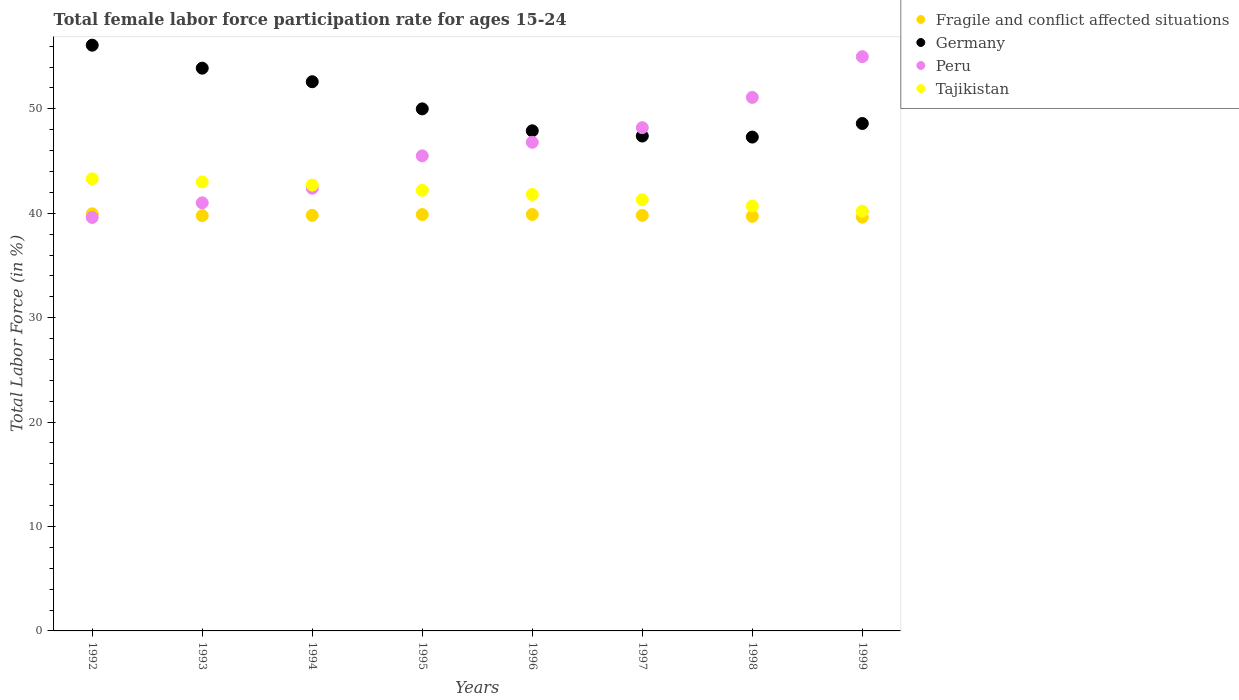Is the number of dotlines equal to the number of legend labels?
Provide a short and direct response. Yes. Across all years, what is the maximum female labor force participation rate in Tajikistan?
Keep it short and to the point. 43.3. Across all years, what is the minimum female labor force participation rate in Peru?
Ensure brevity in your answer.  39.6. What is the total female labor force participation rate in Peru in the graph?
Provide a short and direct response. 369.6. What is the difference between the female labor force participation rate in Germany in 1998 and that in 1999?
Offer a very short reply. -1.3. What is the difference between the female labor force participation rate in Fragile and conflict affected situations in 1998 and the female labor force participation rate in Germany in 1996?
Make the answer very short. -8.19. What is the average female labor force participation rate in Fragile and conflict affected situations per year?
Your response must be concise. 39.8. In the year 1993, what is the difference between the female labor force participation rate in Tajikistan and female labor force participation rate in Fragile and conflict affected situations?
Offer a terse response. 3.23. What is the ratio of the female labor force participation rate in Fragile and conflict affected situations in 1992 to that in 1998?
Your response must be concise. 1.01. Is the difference between the female labor force participation rate in Tajikistan in 1994 and 1999 greater than the difference between the female labor force participation rate in Fragile and conflict affected situations in 1994 and 1999?
Your response must be concise. Yes. What is the difference between the highest and the second highest female labor force participation rate in Tajikistan?
Offer a very short reply. 0.3. What is the difference between the highest and the lowest female labor force participation rate in Tajikistan?
Your answer should be compact. 3.1. In how many years, is the female labor force participation rate in Fragile and conflict affected situations greater than the average female labor force participation rate in Fragile and conflict affected situations taken over all years?
Provide a short and direct response. 4. Is the sum of the female labor force participation rate in Peru in 1997 and 1999 greater than the maximum female labor force participation rate in Tajikistan across all years?
Your answer should be very brief. Yes. Is it the case that in every year, the sum of the female labor force participation rate in Peru and female labor force participation rate in Germany  is greater than the female labor force participation rate in Tajikistan?
Your answer should be very brief. Yes. Is the female labor force participation rate in Fragile and conflict affected situations strictly less than the female labor force participation rate in Germany over the years?
Your response must be concise. Yes. How many years are there in the graph?
Provide a short and direct response. 8. Where does the legend appear in the graph?
Offer a very short reply. Top right. How many legend labels are there?
Your answer should be compact. 4. How are the legend labels stacked?
Make the answer very short. Vertical. What is the title of the graph?
Offer a very short reply. Total female labor force participation rate for ages 15-24. What is the Total Labor Force (in %) of Fragile and conflict affected situations in 1992?
Offer a very short reply. 39.95. What is the Total Labor Force (in %) of Germany in 1992?
Provide a succinct answer. 56.1. What is the Total Labor Force (in %) of Peru in 1992?
Give a very brief answer. 39.6. What is the Total Labor Force (in %) in Tajikistan in 1992?
Provide a short and direct response. 43.3. What is the Total Labor Force (in %) of Fragile and conflict affected situations in 1993?
Offer a very short reply. 39.77. What is the Total Labor Force (in %) in Germany in 1993?
Your answer should be very brief. 53.9. What is the Total Labor Force (in %) of Fragile and conflict affected situations in 1994?
Your answer should be very brief. 39.8. What is the Total Labor Force (in %) of Germany in 1994?
Offer a very short reply. 52.6. What is the Total Labor Force (in %) of Peru in 1994?
Keep it short and to the point. 42.4. What is the Total Labor Force (in %) of Tajikistan in 1994?
Offer a terse response. 42.7. What is the Total Labor Force (in %) of Fragile and conflict affected situations in 1995?
Give a very brief answer. 39.88. What is the Total Labor Force (in %) of Peru in 1995?
Make the answer very short. 45.5. What is the Total Labor Force (in %) in Tajikistan in 1995?
Give a very brief answer. 42.2. What is the Total Labor Force (in %) in Fragile and conflict affected situations in 1996?
Your answer should be very brief. 39.89. What is the Total Labor Force (in %) of Germany in 1996?
Ensure brevity in your answer.  47.9. What is the Total Labor Force (in %) in Peru in 1996?
Your response must be concise. 46.8. What is the Total Labor Force (in %) of Tajikistan in 1996?
Offer a very short reply. 41.8. What is the Total Labor Force (in %) of Fragile and conflict affected situations in 1997?
Give a very brief answer. 39.8. What is the Total Labor Force (in %) in Germany in 1997?
Offer a very short reply. 47.4. What is the Total Labor Force (in %) in Peru in 1997?
Provide a succinct answer. 48.2. What is the Total Labor Force (in %) of Tajikistan in 1997?
Offer a very short reply. 41.3. What is the Total Labor Force (in %) of Fragile and conflict affected situations in 1998?
Offer a very short reply. 39.71. What is the Total Labor Force (in %) in Germany in 1998?
Make the answer very short. 47.3. What is the Total Labor Force (in %) of Peru in 1998?
Keep it short and to the point. 51.1. What is the Total Labor Force (in %) in Tajikistan in 1998?
Offer a very short reply. 40.7. What is the Total Labor Force (in %) of Fragile and conflict affected situations in 1999?
Ensure brevity in your answer.  39.63. What is the Total Labor Force (in %) of Germany in 1999?
Make the answer very short. 48.6. What is the Total Labor Force (in %) of Tajikistan in 1999?
Your response must be concise. 40.2. Across all years, what is the maximum Total Labor Force (in %) of Fragile and conflict affected situations?
Your answer should be very brief. 39.95. Across all years, what is the maximum Total Labor Force (in %) of Germany?
Your answer should be very brief. 56.1. Across all years, what is the maximum Total Labor Force (in %) in Peru?
Your answer should be compact. 55. Across all years, what is the maximum Total Labor Force (in %) of Tajikistan?
Your answer should be very brief. 43.3. Across all years, what is the minimum Total Labor Force (in %) of Fragile and conflict affected situations?
Provide a short and direct response. 39.63. Across all years, what is the minimum Total Labor Force (in %) of Germany?
Offer a very short reply. 47.3. Across all years, what is the minimum Total Labor Force (in %) in Peru?
Offer a terse response. 39.6. Across all years, what is the minimum Total Labor Force (in %) of Tajikistan?
Make the answer very short. 40.2. What is the total Total Labor Force (in %) of Fragile and conflict affected situations in the graph?
Make the answer very short. 318.42. What is the total Total Labor Force (in %) in Germany in the graph?
Give a very brief answer. 403.8. What is the total Total Labor Force (in %) of Peru in the graph?
Make the answer very short. 369.6. What is the total Total Labor Force (in %) of Tajikistan in the graph?
Provide a succinct answer. 335.2. What is the difference between the Total Labor Force (in %) of Fragile and conflict affected situations in 1992 and that in 1993?
Give a very brief answer. 0.18. What is the difference between the Total Labor Force (in %) in Germany in 1992 and that in 1993?
Make the answer very short. 2.2. What is the difference between the Total Labor Force (in %) of Fragile and conflict affected situations in 1992 and that in 1994?
Give a very brief answer. 0.15. What is the difference between the Total Labor Force (in %) in Tajikistan in 1992 and that in 1994?
Make the answer very short. 0.6. What is the difference between the Total Labor Force (in %) of Fragile and conflict affected situations in 1992 and that in 1995?
Offer a very short reply. 0.07. What is the difference between the Total Labor Force (in %) in Fragile and conflict affected situations in 1992 and that in 1996?
Offer a very short reply. 0.06. What is the difference between the Total Labor Force (in %) of Peru in 1992 and that in 1996?
Provide a short and direct response. -7.2. What is the difference between the Total Labor Force (in %) in Fragile and conflict affected situations in 1992 and that in 1997?
Offer a very short reply. 0.15. What is the difference between the Total Labor Force (in %) in Germany in 1992 and that in 1997?
Your response must be concise. 8.7. What is the difference between the Total Labor Force (in %) of Peru in 1992 and that in 1997?
Offer a very short reply. -8.6. What is the difference between the Total Labor Force (in %) in Tajikistan in 1992 and that in 1997?
Provide a succinct answer. 2. What is the difference between the Total Labor Force (in %) in Fragile and conflict affected situations in 1992 and that in 1998?
Make the answer very short. 0.24. What is the difference between the Total Labor Force (in %) in Germany in 1992 and that in 1998?
Ensure brevity in your answer.  8.8. What is the difference between the Total Labor Force (in %) of Tajikistan in 1992 and that in 1998?
Provide a succinct answer. 2.6. What is the difference between the Total Labor Force (in %) of Fragile and conflict affected situations in 1992 and that in 1999?
Provide a short and direct response. 0.32. What is the difference between the Total Labor Force (in %) of Peru in 1992 and that in 1999?
Keep it short and to the point. -15.4. What is the difference between the Total Labor Force (in %) of Fragile and conflict affected situations in 1993 and that in 1994?
Keep it short and to the point. -0.03. What is the difference between the Total Labor Force (in %) in Tajikistan in 1993 and that in 1994?
Make the answer very short. 0.3. What is the difference between the Total Labor Force (in %) in Fragile and conflict affected situations in 1993 and that in 1995?
Give a very brief answer. -0.1. What is the difference between the Total Labor Force (in %) in Peru in 1993 and that in 1995?
Make the answer very short. -4.5. What is the difference between the Total Labor Force (in %) of Fragile and conflict affected situations in 1993 and that in 1996?
Ensure brevity in your answer.  -0.11. What is the difference between the Total Labor Force (in %) of Fragile and conflict affected situations in 1993 and that in 1997?
Give a very brief answer. -0.03. What is the difference between the Total Labor Force (in %) in Peru in 1993 and that in 1997?
Your response must be concise. -7.2. What is the difference between the Total Labor Force (in %) in Tajikistan in 1993 and that in 1997?
Provide a succinct answer. 1.7. What is the difference between the Total Labor Force (in %) in Fragile and conflict affected situations in 1993 and that in 1998?
Offer a terse response. 0.06. What is the difference between the Total Labor Force (in %) in Peru in 1993 and that in 1998?
Provide a short and direct response. -10.1. What is the difference between the Total Labor Force (in %) of Fragile and conflict affected situations in 1993 and that in 1999?
Provide a succinct answer. 0.15. What is the difference between the Total Labor Force (in %) in Germany in 1993 and that in 1999?
Your response must be concise. 5.3. What is the difference between the Total Labor Force (in %) of Tajikistan in 1993 and that in 1999?
Ensure brevity in your answer.  2.8. What is the difference between the Total Labor Force (in %) of Fragile and conflict affected situations in 1994 and that in 1995?
Offer a very short reply. -0.07. What is the difference between the Total Labor Force (in %) in Germany in 1994 and that in 1995?
Your response must be concise. 2.6. What is the difference between the Total Labor Force (in %) of Fragile and conflict affected situations in 1994 and that in 1996?
Your answer should be compact. -0.08. What is the difference between the Total Labor Force (in %) in Germany in 1994 and that in 1996?
Your response must be concise. 4.7. What is the difference between the Total Labor Force (in %) of Fragile and conflict affected situations in 1994 and that in 1997?
Offer a very short reply. 0. What is the difference between the Total Labor Force (in %) of Germany in 1994 and that in 1997?
Provide a succinct answer. 5.2. What is the difference between the Total Labor Force (in %) of Peru in 1994 and that in 1997?
Your answer should be compact. -5.8. What is the difference between the Total Labor Force (in %) in Tajikistan in 1994 and that in 1997?
Ensure brevity in your answer.  1.4. What is the difference between the Total Labor Force (in %) in Fragile and conflict affected situations in 1994 and that in 1998?
Provide a succinct answer. 0.09. What is the difference between the Total Labor Force (in %) of Peru in 1994 and that in 1998?
Offer a terse response. -8.7. What is the difference between the Total Labor Force (in %) in Tajikistan in 1994 and that in 1998?
Keep it short and to the point. 2. What is the difference between the Total Labor Force (in %) in Fragile and conflict affected situations in 1994 and that in 1999?
Your answer should be very brief. 0.18. What is the difference between the Total Labor Force (in %) of Germany in 1994 and that in 1999?
Provide a short and direct response. 4. What is the difference between the Total Labor Force (in %) of Tajikistan in 1994 and that in 1999?
Offer a terse response. 2.5. What is the difference between the Total Labor Force (in %) of Fragile and conflict affected situations in 1995 and that in 1996?
Your response must be concise. -0.01. What is the difference between the Total Labor Force (in %) of Germany in 1995 and that in 1996?
Give a very brief answer. 2.1. What is the difference between the Total Labor Force (in %) of Peru in 1995 and that in 1996?
Ensure brevity in your answer.  -1.3. What is the difference between the Total Labor Force (in %) in Tajikistan in 1995 and that in 1996?
Offer a very short reply. 0.4. What is the difference between the Total Labor Force (in %) in Fragile and conflict affected situations in 1995 and that in 1997?
Give a very brief answer. 0.08. What is the difference between the Total Labor Force (in %) in Peru in 1995 and that in 1997?
Provide a short and direct response. -2.7. What is the difference between the Total Labor Force (in %) of Tajikistan in 1995 and that in 1997?
Provide a succinct answer. 0.9. What is the difference between the Total Labor Force (in %) in Fragile and conflict affected situations in 1995 and that in 1998?
Ensure brevity in your answer.  0.17. What is the difference between the Total Labor Force (in %) in Peru in 1995 and that in 1998?
Give a very brief answer. -5.6. What is the difference between the Total Labor Force (in %) of Fragile and conflict affected situations in 1995 and that in 1999?
Ensure brevity in your answer.  0.25. What is the difference between the Total Labor Force (in %) of Germany in 1995 and that in 1999?
Give a very brief answer. 1.4. What is the difference between the Total Labor Force (in %) of Peru in 1995 and that in 1999?
Your response must be concise. -9.5. What is the difference between the Total Labor Force (in %) of Tajikistan in 1995 and that in 1999?
Offer a terse response. 2. What is the difference between the Total Labor Force (in %) of Fragile and conflict affected situations in 1996 and that in 1997?
Ensure brevity in your answer.  0.09. What is the difference between the Total Labor Force (in %) in Germany in 1996 and that in 1997?
Your response must be concise. 0.5. What is the difference between the Total Labor Force (in %) of Peru in 1996 and that in 1997?
Offer a very short reply. -1.4. What is the difference between the Total Labor Force (in %) in Tajikistan in 1996 and that in 1997?
Offer a terse response. 0.5. What is the difference between the Total Labor Force (in %) in Fragile and conflict affected situations in 1996 and that in 1998?
Provide a short and direct response. 0.18. What is the difference between the Total Labor Force (in %) of Germany in 1996 and that in 1998?
Provide a short and direct response. 0.6. What is the difference between the Total Labor Force (in %) in Peru in 1996 and that in 1998?
Keep it short and to the point. -4.3. What is the difference between the Total Labor Force (in %) of Tajikistan in 1996 and that in 1998?
Provide a succinct answer. 1.1. What is the difference between the Total Labor Force (in %) of Fragile and conflict affected situations in 1996 and that in 1999?
Your response must be concise. 0.26. What is the difference between the Total Labor Force (in %) of Germany in 1996 and that in 1999?
Ensure brevity in your answer.  -0.7. What is the difference between the Total Labor Force (in %) of Fragile and conflict affected situations in 1997 and that in 1998?
Offer a very short reply. 0.09. What is the difference between the Total Labor Force (in %) of Peru in 1997 and that in 1998?
Provide a succinct answer. -2.9. What is the difference between the Total Labor Force (in %) of Tajikistan in 1997 and that in 1998?
Your answer should be compact. 0.6. What is the difference between the Total Labor Force (in %) of Fragile and conflict affected situations in 1997 and that in 1999?
Make the answer very short. 0.17. What is the difference between the Total Labor Force (in %) of Germany in 1997 and that in 1999?
Offer a very short reply. -1.2. What is the difference between the Total Labor Force (in %) of Tajikistan in 1997 and that in 1999?
Give a very brief answer. 1.1. What is the difference between the Total Labor Force (in %) of Fragile and conflict affected situations in 1998 and that in 1999?
Give a very brief answer. 0.08. What is the difference between the Total Labor Force (in %) of Tajikistan in 1998 and that in 1999?
Ensure brevity in your answer.  0.5. What is the difference between the Total Labor Force (in %) in Fragile and conflict affected situations in 1992 and the Total Labor Force (in %) in Germany in 1993?
Your answer should be very brief. -13.95. What is the difference between the Total Labor Force (in %) in Fragile and conflict affected situations in 1992 and the Total Labor Force (in %) in Peru in 1993?
Give a very brief answer. -1.05. What is the difference between the Total Labor Force (in %) in Fragile and conflict affected situations in 1992 and the Total Labor Force (in %) in Tajikistan in 1993?
Keep it short and to the point. -3.05. What is the difference between the Total Labor Force (in %) in Germany in 1992 and the Total Labor Force (in %) in Peru in 1993?
Your response must be concise. 15.1. What is the difference between the Total Labor Force (in %) in Peru in 1992 and the Total Labor Force (in %) in Tajikistan in 1993?
Make the answer very short. -3.4. What is the difference between the Total Labor Force (in %) of Fragile and conflict affected situations in 1992 and the Total Labor Force (in %) of Germany in 1994?
Offer a very short reply. -12.65. What is the difference between the Total Labor Force (in %) in Fragile and conflict affected situations in 1992 and the Total Labor Force (in %) in Peru in 1994?
Make the answer very short. -2.45. What is the difference between the Total Labor Force (in %) of Fragile and conflict affected situations in 1992 and the Total Labor Force (in %) of Tajikistan in 1994?
Offer a terse response. -2.75. What is the difference between the Total Labor Force (in %) in Germany in 1992 and the Total Labor Force (in %) in Tajikistan in 1994?
Make the answer very short. 13.4. What is the difference between the Total Labor Force (in %) of Fragile and conflict affected situations in 1992 and the Total Labor Force (in %) of Germany in 1995?
Your answer should be compact. -10.05. What is the difference between the Total Labor Force (in %) in Fragile and conflict affected situations in 1992 and the Total Labor Force (in %) in Peru in 1995?
Make the answer very short. -5.55. What is the difference between the Total Labor Force (in %) in Fragile and conflict affected situations in 1992 and the Total Labor Force (in %) in Tajikistan in 1995?
Your answer should be compact. -2.25. What is the difference between the Total Labor Force (in %) in Germany in 1992 and the Total Labor Force (in %) in Tajikistan in 1995?
Your answer should be compact. 13.9. What is the difference between the Total Labor Force (in %) in Fragile and conflict affected situations in 1992 and the Total Labor Force (in %) in Germany in 1996?
Offer a very short reply. -7.95. What is the difference between the Total Labor Force (in %) of Fragile and conflict affected situations in 1992 and the Total Labor Force (in %) of Peru in 1996?
Provide a succinct answer. -6.85. What is the difference between the Total Labor Force (in %) in Fragile and conflict affected situations in 1992 and the Total Labor Force (in %) in Tajikistan in 1996?
Offer a terse response. -1.85. What is the difference between the Total Labor Force (in %) in Germany in 1992 and the Total Labor Force (in %) in Tajikistan in 1996?
Your answer should be very brief. 14.3. What is the difference between the Total Labor Force (in %) in Peru in 1992 and the Total Labor Force (in %) in Tajikistan in 1996?
Your answer should be very brief. -2.2. What is the difference between the Total Labor Force (in %) in Fragile and conflict affected situations in 1992 and the Total Labor Force (in %) in Germany in 1997?
Your answer should be very brief. -7.45. What is the difference between the Total Labor Force (in %) in Fragile and conflict affected situations in 1992 and the Total Labor Force (in %) in Peru in 1997?
Provide a succinct answer. -8.25. What is the difference between the Total Labor Force (in %) of Fragile and conflict affected situations in 1992 and the Total Labor Force (in %) of Tajikistan in 1997?
Your response must be concise. -1.35. What is the difference between the Total Labor Force (in %) in Peru in 1992 and the Total Labor Force (in %) in Tajikistan in 1997?
Your answer should be very brief. -1.7. What is the difference between the Total Labor Force (in %) of Fragile and conflict affected situations in 1992 and the Total Labor Force (in %) of Germany in 1998?
Provide a succinct answer. -7.35. What is the difference between the Total Labor Force (in %) of Fragile and conflict affected situations in 1992 and the Total Labor Force (in %) of Peru in 1998?
Offer a very short reply. -11.15. What is the difference between the Total Labor Force (in %) of Fragile and conflict affected situations in 1992 and the Total Labor Force (in %) of Tajikistan in 1998?
Provide a succinct answer. -0.75. What is the difference between the Total Labor Force (in %) in Germany in 1992 and the Total Labor Force (in %) in Peru in 1998?
Offer a very short reply. 5. What is the difference between the Total Labor Force (in %) in Fragile and conflict affected situations in 1992 and the Total Labor Force (in %) in Germany in 1999?
Provide a short and direct response. -8.65. What is the difference between the Total Labor Force (in %) of Fragile and conflict affected situations in 1992 and the Total Labor Force (in %) of Peru in 1999?
Ensure brevity in your answer.  -15.05. What is the difference between the Total Labor Force (in %) in Fragile and conflict affected situations in 1992 and the Total Labor Force (in %) in Tajikistan in 1999?
Give a very brief answer. -0.25. What is the difference between the Total Labor Force (in %) of Germany in 1992 and the Total Labor Force (in %) of Peru in 1999?
Provide a short and direct response. 1.1. What is the difference between the Total Labor Force (in %) in Germany in 1992 and the Total Labor Force (in %) in Tajikistan in 1999?
Ensure brevity in your answer.  15.9. What is the difference between the Total Labor Force (in %) of Fragile and conflict affected situations in 1993 and the Total Labor Force (in %) of Germany in 1994?
Your answer should be compact. -12.83. What is the difference between the Total Labor Force (in %) in Fragile and conflict affected situations in 1993 and the Total Labor Force (in %) in Peru in 1994?
Offer a terse response. -2.63. What is the difference between the Total Labor Force (in %) in Fragile and conflict affected situations in 1993 and the Total Labor Force (in %) in Tajikistan in 1994?
Provide a short and direct response. -2.93. What is the difference between the Total Labor Force (in %) in Peru in 1993 and the Total Labor Force (in %) in Tajikistan in 1994?
Your answer should be compact. -1.7. What is the difference between the Total Labor Force (in %) in Fragile and conflict affected situations in 1993 and the Total Labor Force (in %) in Germany in 1995?
Give a very brief answer. -10.23. What is the difference between the Total Labor Force (in %) of Fragile and conflict affected situations in 1993 and the Total Labor Force (in %) of Peru in 1995?
Offer a terse response. -5.73. What is the difference between the Total Labor Force (in %) of Fragile and conflict affected situations in 1993 and the Total Labor Force (in %) of Tajikistan in 1995?
Offer a terse response. -2.43. What is the difference between the Total Labor Force (in %) in Fragile and conflict affected situations in 1993 and the Total Labor Force (in %) in Germany in 1996?
Make the answer very short. -8.13. What is the difference between the Total Labor Force (in %) in Fragile and conflict affected situations in 1993 and the Total Labor Force (in %) in Peru in 1996?
Your answer should be compact. -7.03. What is the difference between the Total Labor Force (in %) in Fragile and conflict affected situations in 1993 and the Total Labor Force (in %) in Tajikistan in 1996?
Your answer should be very brief. -2.03. What is the difference between the Total Labor Force (in %) in Germany in 1993 and the Total Labor Force (in %) in Peru in 1996?
Offer a terse response. 7.1. What is the difference between the Total Labor Force (in %) in Fragile and conflict affected situations in 1993 and the Total Labor Force (in %) in Germany in 1997?
Offer a terse response. -7.63. What is the difference between the Total Labor Force (in %) in Fragile and conflict affected situations in 1993 and the Total Labor Force (in %) in Peru in 1997?
Your answer should be very brief. -8.43. What is the difference between the Total Labor Force (in %) in Fragile and conflict affected situations in 1993 and the Total Labor Force (in %) in Tajikistan in 1997?
Your response must be concise. -1.53. What is the difference between the Total Labor Force (in %) of Germany in 1993 and the Total Labor Force (in %) of Peru in 1997?
Your answer should be compact. 5.7. What is the difference between the Total Labor Force (in %) in Germany in 1993 and the Total Labor Force (in %) in Tajikistan in 1997?
Your answer should be compact. 12.6. What is the difference between the Total Labor Force (in %) of Fragile and conflict affected situations in 1993 and the Total Labor Force (in %) of Germany in 1998?
Make the answer very short. -7.53. What is the difference between the Total Labor Force (in %) in Fragile and conflict affected situations in 1993 and the Total Labor Force (in %) in Peru in 1998?
Offer a terse response. -11.33. What is the difference between the Total Labor Force (in %) of Fragile and conflict affected situations in 1993 and the Total Labor Force (in %) of Tajikistan in 1998?
Keep it short and to the point. -0.93. What is the difference between the Total Labor Force (in %) in Germany in 1993 and the Total Labor Force (in %) in Tajikistan in 1998?
Provide a short and direct response. 13.2. What is the difference between the Total Labor Force (in %) of Peru in 1993 and the Total Labor Force (in %) of Tajikistan in 1998?
Make the answer very short. 0.3. What is the difference between the Total Labor Force (in %) of Fragile and conflict affected situations in 1993 and the Total Labor Force (in %) of Germany in 1999?
Your answer should be compact. -8.83. What is the difference between the Total Labor Force (in %) in Fragile and conflict affected situations in 1993 and the Total Labor Force (in %) in Peru in 1999?
Offer a terse response. -15.23. What is the difference between the Total Labor Force (in %) in Fragile and conflict affected situations in 1993 and the Total Labor Force (in %) in Tajikistan in 1999?
Offer a very short reply. -0.43. What is the difference between the Total Labor Force (in %) of Germany in 1993 and the Total Labor Force (in %) of Peru in 1999?
Keep it short and to the point. -1.1. What is the difference between the Total Labor Force (in %) in Germany in 1993 and the Total Labor Force (in %) in Tajikistan in 1999?
Provide a short and direct response. 13.7. What is the difference between the Total Labor Force (in %) of Peru in 1993 and the Total Labor Force (in %) of Tajikistan in 1999?
Your answer should be very brief. 0.8. What is the difference between the Total Labor Force (in %) in Fragile and conflict affected situations in 1994 and the Total Labor Force (in %) in Germany in 1995?
Make the answer very short. -10.2. What is the difference between the Total Labor Force (in %) of Fragile and conflict affected situations in 1994 and the Total Labor Force (in %) of Peru in 1995?
Give a very brief answer. -5.7. What is the difference between the Total Labor Force (in %) of Fragile and conflict affected situations in 1994 and the Total Labor Force (in %) of Tajikistan in 1995?
Make the answer very short. -2.4. What is the difference between the Total Labor Force (in %) of Germany in 1994 and the Total Labor Force (in %) of Peru in 1995?
Provide a short and direct response. 7.1. What is the difference between the Total Labor Force (in %) in Fragile and conflict affected situations in 1994 and the Total Labor Force (in %) in Germany in 1996?
Give a very brief answer. -8.1. What is the difference between the Total Labor Force (in %) in Fragile and conflict affected situations in 1994 and the Total Labor Force (in %) in Peru in 1996?
Offer a very short reply. -7. What is the difference between the Total Labor Force (in %) of Fragile and conflict affected situations in 1994 and the Total Labor Force (in %) of Tajikistan in 1996?
Give a very brief answer. -2. What is the difference between the Total Labor Force (in %) in Germany in 1994 and the Total Labor Force (in %) in Tajikistan in 1996?
Offer a terse response. 10.8. What is the difference between the Total Labor Force (in %) of Peru in 1994 and the Total Labor Force (in %) of Tajikistan in 1996?
Your answer should be compact. 0.6. What is the difference between the Total Labor Force (in %) of Fragile and conflict affected situations in 1994 and the Total Labor Force (in %) of Germany in 1997?
Provide a succinct answer. -7.6. What is the difference between the Total Labor Force (in %) in Fragile and conflict affected situations in 1994 and the Total Labor Force (in %) in Peru in 1997?
Your answer should be compact. -8.4. What is the difference between the Total Labor Force (in %) of Fragile and conflict affected situations in 1994 and the Total Labor Force (in %) of Tajikistan in 1997?
Offer a very short reply. -1.5. What is the difference between the Total Labor Force (in %) in Germany in 1994 and the Total Labor Force (in %) in Peru in 1997?
Provide a succinct answer. 4.4. What is the difference between the Total Labor Force (in %) of Fragile and conflict affected situations in 1994 and the Total Labor Force (in %) of Germany in 1998?
Ensure brevity in your answer.  -7.5. What is the difference between the Total Labor Force (in %) of Fragile and conflict affected situations in 1994 and the Total Labor Force (in %) of Peru in 1998?
Offer a terse response. -11.3. What is the difference between the Total Labor Force (in %) in Fragile and conflict affected situations in 1994 and the Total Labor Force (in %) in Tajikistan in 1998?
Keep it short and to the point. -0.9. What is the difference between the Total Labor Force (in %) of Germany in 1994 and the Total Labor Force (in %) of Peru in 1998?
Your answer should be very brief. 1.5. What is the difference between the Total Labor Force (in %) of Peru in 1994 and the Total Labor Force (in %) of Tajikistan in 1998?
Offer a terse response. 1.7. What is the difference between the Total Labor Force (in %) in Fragile and conflict affected situations in 1994 and the Total Labor Force (in %) in Germany in 1999?
Your answer should be very brief. -8.8. What is the difference between the Total Labor Force (in %) of Fragile and conflict affected situations in 1994 and the Total Labor Force (in %) of Peru in 1999?
Your answer should be very brief. -15.2. What is the difference between the Total Labor Force (in %) in Fragile and conflict affected situations in 1994 and the Total Labor Force (in %) in Tajikistan in 1999?
Keep it short and to the point. -0.4. What is the difference between the Total Labor Force (in %) of Germany in 1994 and the Total Labor Force (in %) of Tajikistan in 1999?
Provide a short and direct response. 12.4. What is the difference between the Total Labor Force (in %) in Peru in 1994 and the Total Labor Force (in %) in Tajikistan in 1999?
Keep it short and to the point. 2.2. What is the difference between the Total Labor Force (in %) of Fragile and conflict affected situations in 1995 and the Total Labor Force (in %) of Germany in 1996?
Ensure brevity in your answer.  -8.03. What is the difference between the Total Labor Force (in %) in Fragile and conflict affected situations in 1995 and the Total Labor Force (in %) in Peru in 1996?
Your response must be concise. -6.92. What is the difference between the Total Labor Force (in %) in Fragile and conflict affected situations in 1995 and the Total Labor Force (in %) in Tajikistan in 1996?
Provide a short and direct response. -1.93. What is the difference between the Total Labor Force (in %) of Germany in 1995 and the Total Labor Force (in %) of Tajikistan in 1996?
Keep it short and to the point. 8.2. What is the difference between the Total Labor Force (in %) of Peru in 1995 and the Total Labor Force (in %) of Tajikistan in 1996?
Give a very brief answer. 3.7. What is the difference between the Total Labor Force (in %) in Fragile and conflict affected situations in 1995 and the Total Labor Force (in %) in Germany in 1997?
Your answer should be compact. -7.53. What is the difference between the Total Labor Force (in %) of Fragile and conflict affected situations in 1995 and the Total Labor Force (in %) of Peru in 1997?
Keep it short and to the point. -8.32. What is the difference between the Total Labor Force (in %) in Fragile and conflict affected situations in 1995 and the Total Labor Force (in %) in Tajikistan in 1997?
Offer a very short reply. -1.43. What is the difference between the Total Labor Force (in %) in Germany in 1995 and the Total Labor Force (in %) in Tajikistan in 1997?
Ensure brevity in your answer.  8.7. What is the difference between the Total Labor Force (in %) of Peru in 1995 and the Total Labor Force (in %) of Tajikistan in 1997?
Make the answer very short. 4.2. What is the difference between the Total Labor Force (in %) in Fragile and conflict affected situations in 1995 and the Total Labor Force (in %) in Germany in 1998?
Provide a succinct answer. -7.42. What is the difference between the Total Labor Force (in %) of Fragile and conflict affected situations in 1995 and the Total Labor Force (in %) of Peru in 1998?
Provide a succinct answer. -11.22. What is the difference between the Total Labor Force (in %) in Fragile and conflict affected situations in 1995 and the Total Labor Force (in %) in Tajikistan in 1998?
Your answer should be compact. -0.82. What is the difference between the Total Labor Force (in %) in Germany in 1995 and the Total Labor Force (in %) in Peru in 1998?
Ensure brevity in your answer.  -1.1. What is the difference between the Total Labor Force (in %) of Fragile and conflict affected situations in 1995 and the Total Labor Force (in %) of Germany in 1999?
Ensure brevity in your answer.  -8.72. What is the difference between the Total Labor Force (in %) in Fragile and conflict affected situations in 1995 and the Total Labor Force (in %) in Peru in 1999?
Make the answer very short. -15.12. What is the difference between the Total Labor Force (in %) in Fragile and conflict affected situations in 1995 and the Total Labor Force (in %) in Tajikistan in 1999?
Offer a terse response. -0.33. What is the difference between the Total Labor Force (in %) in Germany in 1995 and the Total Labor Force (in %) in Tajikistan in 1999?
Your answer should be compact. 9.8. What is the difference between the Total Labor Force (in %) in Peru in 1995 and the Total Labor Force (in %) in Tajikistan in 1999?
Provide a succinct answer. 5.3. What is the difference between the Total Labor Force (in %) in Fragile and conflict affected situations in 1996 and the Total Labor Force (in %) in Germany in 1997?
Your response must be concise. -7.51. What is the difference between the Total Labor Force (in %) in Fragile and conflict affected situations in 1996 and the Total Labor Force (in %) in Peru in 1997?
Your answer should be compact. -8.31. What is the difference between the Total Labor Force (in %) in Fragile and conflict affected situations in 1996 and the Total Labor Force (in %) in Tajikistan in 1997?
Ensure brevity in your answer.  -1.41. What is the difference between the Total Labor Force (in %) of Germany in 1996 and the Total Labor Force (in %) of Peru in 1997?
Give a very brief answer. -0.3. What is the difference between the Total Labor Force (in %) in Germany in 1996 and the Total Labor Force (in %) in Tajikistan in 1997?
Offer a terse response. 6.6. What is the difference between the Total Labor Force (in %) of Peru in 1996 and the Total Labor Force (in %) of Tajikistan in 1997?
Offer a terse response. 5.5. What is the difference between the Total Labor Force (in %) of Fragile and conflict affected situations in 1996 and the Total Labor Force (in %) of Germany in 1998?
Make the answer very short. -7.41. What is the difference between the Total Labor Force (in %) in Fragile and conflict affected situations in 1996 and the Total Labor Force (in %) in Peru in 1998?
Make the answer very short. -11.21. What is the difference between the Total Labor Force (in %) of Fragile and conflict affected situations in 1996 and the Total Labor Force (in %) of Tajikistan in 1998?
Make the answer very short. -0.81. What is the difference between the Total Labor Force (in %) in Germany in 1996 and the Total Labor Force (in %) in Peru in 1998?
Your answer should be very brief. -3.2. What is the difference between the Total Labor Force (in %) of Peru in 1996 and the Total Labor Force (in %) of Tajikistan in 1998?
Provide a succinct answer. 6.1. What is the difference between the Total Labor Force (in %) of Fragile and conflict affected situations in 1996 and the Total Labor Force (in %) of Germany in 1999?
Give a very brief answer. -8.71. What is the difference between the Total Labor Force (in %) in Fragile and conflict affected situations in 1996 and the Total Labor Force (in %) in Peru in 1999?
Your answer should be compact. -15.11. What is the difference between the Total Labor Force (in %) of Fragile and conflict affected situations in 1996 and the Total Labor Force (in %) of Tajikistan in 1999?
Offer a very short reply. -0.31. What is the difference between the Total Labor Force (in %) of Germany in 1996 and the Total Labor Force (in %) of Tajikistan in 1999?
Your answer should be compact. 7.7. What is the difference between the Total Labor Force (in %) in Fragile and conflict affected situations in 1997 and the Total Labor Force (in %) in Germany in 1998?
Offer a terse response. -7.5. What is the difference between the Total Labor Force (in %) in Fragile and conflict affected situations in 1997 and the Total Labor Force (in %) in Peru in 1998?
Keep it short and to the point. -11.3. What is the difference between the Total Labor Force (in %) of Fragile and conflict affected situations in 1997 and the Total Labor Force (in %) of Tajikistan in 1998?
Your answer should be compact. -0.9. What is the difference between the Total Labor Force (in %) in Fragile and conflict affected situations in 1997 and the Total Labor Force (in %) in Germany in 1999?
Offer a very short reply. -8.8. What is the difference between the Total Labor Force (in %) in Fragile and conflict affected situations in 1997 and the Total Labor Force (in %) in Peru in 1999?
Your answer should be compact. -15.2. What is the difference between the Total Labor Force (in %) in Fragile and conflict affected situations in 1997 and the Total Labor Force (in %) in Tajikistan in 1999?
Offer a very short reply. -0.4. What is the difference between the Total Labor Force (in %) in Peru in 1997 and the Total Labor Force (in %) in Tajikistan in 1999?
Make the answer very short. 8. What is the difference between the Total Labor Force (in %) in Fragile and conflict affected situations in 1998 and the Total Labor Force (in %) in Germany in 1999?
Give a very brief answer. -8.89. What is the difference between the Total Labor Force (in %) of Fragile and conflict affected situations in 1998 and the Total Labor Force (in %) of Peru in 1999?
Your response must be concise. -15.29. What is the difference between the Total Labor Force (in %) of Fragile and conflict affected situations in 1998 and the Total Labor Force (in %) of Tajikistan in 1999?
Provide a short and direct response. -0.49. What is the difference between the Total Labor Force (in %) of Germany in 1998 and the Total Labor Force (in %) of Peru in 1999?
Give a very brief answer. -7.7. What is the difference between the Total Labor Force (in %) of Germany in 1998 and the Total Labor Force (in %) of Tajikistan in 1999?
Offer a very short reply. 7.1. What is the difference between the Total Labor Force (in %) of Peru in 1998 and the Total Labor Force (in %) of Tajikistan in 1999?
Make the answer very short. 10.9. What is the average Total Labor Force (in %) in Fragile and conflict affected situations per year?
Your answer should be very brief. 39.8. What is the average Total Labor Force (in %) in Germany per year?
Keep it short and to the point. 50.48. What is the average Total Labor Force (in %) of Peru per year?
Offer a terse response. 46.2. What is the average Total Labor Force (in %) of Tajikistan per year?
Provide a succinct answer. 41.9. In the year 1992, what is the difference between the Total Labor Force (in %) in Fragile and conflict affected situations and Total Labor Force (in %) in Germany?
Offer a terse response. -16.15. In the year 1992, what is the difference between the Total Labor Force (in %) of Fragile and conflict affected situations and Total Labor Force (in %) of Peru?
Provide a succinct answer. 0.35. In the year 1992, what is the difference between the Total Labor Force (in %) of Fragile and conflict affected situations and Total Labor Force (in %) of Tajikistan?
Your answer should be very brief. -3.35. In the year 1992, what is the difference between the Total Labor Force (in %) in Peru and Total Labor Force (in %) in Tajikistan?
Give a very brief answer. -3.7. In the year 1993, what is the difference between the Total Labor Force (in %) of Fragile and conflict affected situations and Total Labor Force (in %) of Germany?
Give a very brief answer. -14.13. In the year 1993, what is the difference between the Total Labor Force (in %) of Fragile and conflict affected situations and Total Labor Force (in %) of Peru?
Keep it short and to the point. -1.23. In the year 1993, what is the difference between the Total Labor Force (in %) of Fragile and conflict affected situations and Total Labor Force (in %) of Tajikistan?
Offer a terse response. -3.23. In the year 1993, what is the difference between the Total Labor Force (in %) of Germany and Total Labor Force (in %) of Peru?
Your answer should be very brief. 12.9. In the year 1993, what is the difference between the Total Labor Force (in %) of Germany and Total Labor Force (in %) of Tajikistan?
Your answer should be very brief. 10.9. In the year 1994, what is the difference between the Total Labor Force (in %) of Fragile and conflict affected situations and Total Labor Force (in %) of Germany?
Offer a very short reply. -12.8. In the year 1994, what is the difference between the Total Labor Force (in %) in Fragile and conflict affected situations and Total Labor Force (in %) in Peru?
Ensure brevity in your answer.  -2.6. In the year 1994, what is the difference between the Total Labor Force (in %) in Fragile and conflict affected situations and Total Labor Force (in %) in Tajikistan?
Your answer should be compact. -2.9. In the year 1994, what is the difference between the Total Labor Force (in %) in Germany and Total Labor Force (in %) in Peru?
Offer a terse response. 10.2. In the year 1994, what is the difference between the Total Labor Force (in %) of Germany and Total Labor Force (in %) of Tajikistan?
Provide a succinct answer. 9.9. In the year 1994, what is the difference between the Total Labor Force (in %) in Peru and Total Labor Force (in %) in Tajikistan?
Provide a succinct answer. -0.3. In the year 1995, what is the difference between the Total Labor Force (in %) in Fragile and conflict affected situations and Total Labor Force (in %) in Germany?
Offer a terse response. -10.12. In the year 1995, what is the difference between the Total Labor Force (in %) in Fragile and conflict affected situations and Total Labor Force (in %) in Peru?
Give a very brief answer. -5.62. In the year 1995, what is the difference between the Total Labor Force (in %) in Fragile and conflict affected situations and Total Labor Force (in %) in Tajikistan?
Your answer should be very brief. -2.33. In the year 1995, what is the difference between the Total Labor Force (in %) in Germany and Total Labor Force (in %) in Tajikistan?
Provide a short and direct response. 7.8. In the year 1996, what is the difference between the Total Labor Force (in %) in Fragile and conflict affected situations and Total Labor Force (in %) in Germany?
Provide a short and direct response. -8.01. In the year 1996, what is the difference between the Total Labor Force (in %) of Fragile and conflict affected situations and Total Labor Force (in %) of Peru?
Provide a short and direct response. -6.91. In the year 1996, what is the difference between the Total Labor Force (in %) in Fragile and conflict affected situations and Total Labor Force (in %) in Tajikistan?
Ensure brevity in your answer.  -1.91. In the year 1996, what is the difference between the Total Labor Force (in %) of Germany and Total Labor Force (in %) of Tajikistan?
Offer a terse response. 6.1. In the year 1996, what is the difference between the Total Labor Force (in %) of Peru and Total Labor Force (in %) of Tajikistan?
Make the answer very short. 5. In the year 1997, what is the difference between the Total Labor Force (in %) of Fragile and conflict affected situations and Total Labor Force (in %) of Germany?
Your answer should be very brief. -7.6. In the year 1997, what is the difference between the Total Labor Force (in %) of Fragile and conflict affected situations and Total Labor Force (in %) of Peru?
Your answer should be very brief. -8.4. In the year 1997, what is the difference between the Total Labor Force (in %) of Fragile and conflict affected situations and Total Labor Force (in %) of Tajikistan?
Keep it short and to the point. -1.5. In the year 1997, what is the difference between the Total Labor Force (in %) of Germany and Total Labor Force (in %) of Tajikistan?
Give a very brief answer. 6.1. In the year 1998, what is the difference between the Total Labor Force (in %) of Fragile and conflict affected situations and Total Labor Force (in %) of Germany?
Ensure brevity in your answer.  -7.59. In the year 1998, what is the difference between the Total Labor Force (in %) in Fragile and conflict affected situations and Total Labor Force (in %) in Peru?
Offer a very short reply. -11.39. In the year 1998, what is the difference between the Total Labor Force (in %) in Fragile and conflict affected situations and Total Labor Force (in %) in Tajikistan?
Give a very brief answer. -0.99. In the year 1998, what is the difference between the Total Labor Force (in %) of Germany and Total Labor Force (in %) of Peru?
Your response must be concise. -3.8. In the year 1998, what is the difference between the Total Labor Force (in %) in Peru and Total Labor Force (in %) in Tajikistan?
Your response must be concise. 10.4. In the year 1999, what is the difference between the Total Labor Force (in %) of Fragile and conflict affected situations and Total Labor Force (in %) of Germany?
Give a very brief answer. -8.97. In the year 1999, what is the difference between the Total Labor Force (in %) of Fragile and conflict affected situations and Total Labor Force (in %) of Peru?
Provide a short and direct response. -15.37. In the year 1999, what is the difference between the Total Labor Force (in %) in Fragile and conflict affected situations and Total Labor Force (in %) in Tajikistan?
Offer a very short reply. -0.57. In the year 1999, what is the difference between the Total Labor Force (in %) in Germany and Total Labor Force (in %) in Peru?
Offer a terse response. -6.4. In the year 1999, what is the difference between the Total Labor Force (in %) in Germany and Total Labor Force (in %) in Tajikistan?
Give a very brief answer. 8.4. What is the ratio of the Total Labor Force (in %) of Germany in 1992 to that in 1993?
Make the answer very short. 1.04. What is the ratio of the Total Labor Force (in %) in Peru in 1992 to that in 1993?
Offer a very short reply. 0.97. What is the ratio of the Total Labor Force (in %) of Tajikistan in 1992 to that in 1993?
Make the answer very short. 1.01. What is the ratio of the Total Labor Force (in %) in Germany in 1992 to that in 1994?
Keep it short and to the point. 1.07. What is the ratio of the Total Labor Force (in %) of Peru in 1992 to that in 1994?
Provide a succinct answer. 0.93. What is the ratio of the Total Labor Force (in %) of Tajikistan in 1992 to that in 1994?
Your answer should be very brief. 1.01. What is the ratio of the Total Labor Force (in %) of Germany in 1992 to that in 1995?
Your response must be concise. 1.12. What is the ratio of the Total Labor Force (in %) of Peru in 1992 to that in 1995?
Provide a short and direct response. 0.87. What is the ratio of the Total Labor Force (in %) of Tajikistan in 1992 to that in 1995?
Your answer should be compact. 1.03. What is the ratio of the Total Labor Force (in %) of Fragile and conflict affected situations in 1992 to that in 1996?
Keep it short and to the point. 1. What is the ratio of the Total Labor Force (in %) of Germany in 1992 to that in 1996?
Your response must be concise. 1.17. What is the ratio of the Total Labor Force (in %) in Peru in 1992 to that in 1996?
Provide a succinct answer. 0.85. What is the ratio of the Total Labor Force (in %) in Tajikistan in 1992 to that in 1996?
Keep it short and to the point. 1.04. What is the ratio of the Total Labor Force (in %) of Fragile and conflict affected situations in 1992 to that in 1997?
Make the answer very short. 1. What is the ratio of the Total Labor Force (in %) of Germany in 1992 to that in 1997?
Your answer should be compact. 1.18. What is the ratio of the Total Labor Force (in %) in Peru in 1992 to that in 1997?
Make the answer very short. 0.82. What is the ratio of the Total Labor Force (in %) of Tajikistan in 1992 to that in 1997?
Ensure brevity in your answer.  1.05. What is the ratio of the Total Labor Force (in %) of Fragile and conflict affected situations in 1992 to that in 1998?
Make the answer very short. 1.01. What is the ratio of the Total Labor Force (in %) of Germany in 1992 to that in 1998?
Provide a short and direct response. 1.19. What is the ratio of the Total Labor Force (in %) in Peru in 1992 to that in 1998?
Your answer should be very brief. 0.78. What is the ratio of the Total Labor Force (in %) in Tajikistan in 1992 to that in 1998?
Your answer should be compact. 1.06. What is the ratio of the Total Labor Force (in %) of Fragile and conflict affected situations in 1992 to that in 1999?
Provide a short and direct response. 1.01. What is the ratio of the Total Labor Force (in %) in Germany in 1992 to that in 1999?
Offer a very short reply. 1.15. What is the ratio of the Total Labor Force (in %) of Peru in 1992 to that in 1999?
Offer a terse response. 0.72. What is the ratio of the Total Labor Force (in %) of Tajikistan in 1992 to that in 1999?
Offer a very short reply. 1.08. What is the ratio of the Total Labor Force (in %) of Fragile and conflict affected situations in 1993 to that in 1994?
Provide a succinct answer. 1. What is the ratio of the Total Labor Force (in %) of Germany in 1993 to that in 1994?
Your response must be concise. 1.02. What is the ratio of the Total Labor Force (in %) of Tajikistan in 1993 to that in 1994?
Your answer should be very brief. 1.01. What is the ratio of the Total Labor Force (in %) of Germany in 1993 to that in 1995?
Your response must be concise. 1.08. What is the ratio of the Total Labor Force (in %) of Peru in 1993 to that in 1995?
Your response must be concise. 0.9. What is the ratio of the Total Labor Force (in %) of Tajikistan in 1993 to that in 1995?
Offer a very short reply. 1.02. What is the ratio of the Total Labor Force (in %) in Germany in 1993 to that in 1996?
Provide a short and direct response. 1.13. What is the ratio of the Total Labor Force (in %) of Peru in 1993 to that in 1996?
Give a very brief answer. 0.88. What is the ratio of the Total Labor Force (in %) of Tajikistan in 1993 to that in 1996?
Make the answer very short. 1.03. What is the ratio of the Total Labor Force (in %) of Germany in 1993 to that in 1997?
Keep it short and to the point. 1.14. What is the ratio of the Total Labor Force (in %) in Peru in 1993 to that in 1997?
Make the answer very short. 0.85. What is the ratio of the Total Labor Force (in %) of Tajikistan in 1993 to that in 1997?
Offer a very short reply. 1.04. What is the ratio of the Total Labor Force (in %) of Germany in 1993 to that in 1998?
Provide a short and direct response. 1.14. What is the ratio of the Total Labor Force (in %) in Peru in 1993 to that in 1998?
Ensure brevity in your answer.  0.8. What is the ratio of the Total Labor Force (in %) of Tajikistan in 1993 to that in 1998?
Provide a succinct answer. 1.06. What is the ratio of the Total Labor Force (in %) in Germany in 1993 to that in 1999?
Give a very brief answer. 1.11. What is the ratio of the Total Labor Force (in %) of Peru in 1993 to that in 1999?
Ensure brevity in your answer.  0.75. What is the ratio of the Total Labor Force (in %) in Tajikistan in 1993 to that in 1999?
Ensure brevity in your answer.  1.07. What is the ratio of the Total Labor Force (in %) of Germany in 1994 to that in 1995?
Your answer should be very brief. 1.05. What is the ratio of the Total Labor Force (in %) in Peru in 1994 to that in 1995?
Provide a succinct answer. 0.93. What is the ratio of the Total Labor Force (in %) in Tajikistan in 1994 to that in 1995?
Keep it short and to the point. 1.01. What is the ratio of the Total Labor Force (in %) in Fragile and conflict affected situations in 1994 to that in 1996?
Make the answer very short. 1. What is the ratio of the Total Labor Force (in %) of Germany in 1994 to that in 1996?
Your answer should be compact. 1.1. What is the ratio of the Total Labor Force (in %) of Peru in 1994 to that in 1996?
Provide a succinct answer. 0.91. What is the ratio of the Total Labor Force (in %) in Tajikistan in 1994 to that in 1996?
Your answer should be very brief. 1.02. What is the ratio of the Total Labor Force (in %) of Fragile and conflict affected situations in 1994 to that in 1997?
Make the answer very short. 1. What is the ratio of the Total Labor Force (in %) in Germany in 1994 to that in 1997?
Offer a very short reply. 1.11. What is the ratio of the Total Labor Force (in %) in Peru in 1994 to that in 1997?
Your response must be concise. 0.88. What is the ratio of the Total Labor Force (in %) in Tajikistan in 1994 to that in 1997?
Your response must be concise. 1.03. What is the ratio of the Total Labor Force (in %) in Germany in 1994 to that in 1998?
Your response must be concise. 1.11. What is the ratio of the Total Labor Force (in %) of Peru in 1994 to that in 1998?
Give a very brief answer. 0.83. What is the ratio of the Total Labor Force (in %) of Tajikistan in 1994 to that in 1998?
Your answer should be very brief. 1.05. What is the ratio of the Total Labor Force (in %) in Germany in 1994 to that in 1999?
Offer a very short reply. 1.08. What is the ratio of the Total Labor Force (in %) in Peru in 1994 to that in 1999?
Your answer should be compact. 0.77. What is the ratio of the Total Labor Force (in %) in Tajikistan in 1994 to that in 1999?
Give a very brief answer. 1.06. What is the ratio of the Total Labor Force (in %) of Fragile and conflict affected situations in 1995 to that in 1996?
Keep it short and to the point. 1. What is the ratio of the Total Labor Force (in %) in Germany in 1995 to that in 1996?
Your answer should be very brief. 1.04. What is the ratio of the Total Labor Force (in %) of Peru in 1995 to that in 1996?
Keep it short and to the point. 0.97. What is the ratio of the Total Labor Force (in %) in Tajikistan in 1995 to that in 1996?
Your response must be concise. 1.01. What is the ratio of the Total Labor Force (in %) in Fragile and conflict affected situations in 1995 to that in 1997?
Make the answer very short. 1. What is the ratio of the Total Labor Force (in %) in Germany in 1995 to that in 1997?
Give a very brief answer. 1.05. What is the ratio of the Total Labor Force (in %) of Peru in 1995 to that in 1997?
Your answer should be compact. 0.94. What is the ratio of the Total Labor Force (in %) in Tajikistan in 1995 to that in 1997?
Your answer should be very brief. 1.02. What is the ratio of the Total Labor Force (in %) in Germany in 1995 to that in 1998?
Offer a very short reply. 1.06. What is the ratio of the Total Labor Force (in %) in Peru in 1995 to that in 1998?
Ensure brevity in your answer.  0.89. What is the ratio of the Total Labor Force (in %) in Tajikistan in 1995 to that in 1998?
Offer a very short reply. 1.04. What is the ratio of the Total Labor Force (in %) of Germany in 1995 to that in 1999?
Keep it short and to the point. 1.03. What is the ratio of the Total Labor Force (in %) of Peru in 1995 to that in 1999?
Offer a terse response. 0.83. What is the ratio of the Total Labor Force (in %) in Tajikistan in 1995 to that in 1999?
Ensure brevity in your answer.  1.05. What is the ratio of the Total Labor Force (in %) of Germany in 1996 to that in 1997?
Keep it short and to the point. 1.01. What is the ratio of the Total Labor Force (in %) in Tajikistan in 1996 to that in 1997?
Your answer should be compact. 1.01. What is the ratio of the Total Labor Force (in %) of Germany in 1996 to that in 1998?
Offer a terse response. 1.01. What is the ratio of the Total Labor Force (in %) of Peru in 1996 to that in 1998?
Offer a terse response. 0.92. What is the ratio of the Total Labor Force (in %) of Fragile and conflict affected situations in 1996 to that in 1999?
Provide a short and direct response. 1.01. What is the ratio of the Total Labor Force (in %) of Germany in 1996 to that in 1999?
Keep it short and to the point. 0.99. What is the ratio of the Total Labor Force (in %) in Peru in 1996 to that in 1999?
Ensure brevity in your answer.  0.85. What is the ratio of the Total Labor Force (in %) in Tajikistan in 1996 to that in 1999?
Ensure brevity in your answer.  1.04. What is the ratio of the Total Labor Force (in %) in Fragile and conflict affected situations in 1997 to that in 1998?
Your response must be concise. 1. What is the ratio of the Total Labor Force (in %) of Germany in 1997 to that in 1998?
Your response must be concise. 1. What is the ratio of the Total Labor Force (in %) of Peru in 1997 to that in 1998?
Your response must be concise. 0.94. What is the ratio of the Total Labor Force (in %) in Tajikistan in 1997 to that in 1998?
Offer a very short reply. 1.01. What is the ratio of the Total Labor Force (in %) of Germany in 1997 to that in 1999?
Ensure brevity in your answer.  0.98. What is the ratio of the Total Labor Force (in %) in Peru in 1997 to that in 1999?
Provide a succinct answer. 0.88. What is the ratio of the Total Labor Force (in %) in Tajikistan in 1997 to that in 1999?
Offer a terse response. 1.03. What is the ratio of the Total Labor Force (in %) of Germany in 1998 to that in 1999?
Your answer should be very brief. 0.97. What is the ratio of the Total Labor Force (in %) in Peru in 1998 to that in 1999?
Your answer should be compact. 0.93. What is the ratio of the Total Labor Force (in %) in Tajikistan in 1998 to that in 1999?
Your answer should be compact. 1.01. What is the difference between the highest and the second highest Total Labor Force (in %) in Fragile and conflict affected situations?
Offer a terse response. 0.06. What is the difference between the highest and the second highest Total Labor Force (in %) of Tajikistan?
Ensure brevity in your answer.  0.3. What is the difference between the highest and the lowest Total Labor Force (in %) of Fragile and conflict affected situations?
Provide a succinct answer. 0.32. What is the difference between the highest and the lowest Total Labor Force (in %) in Tajikistan?
Your answer should be compact. 3.1. 